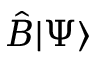<formula> <loc_0><loc_0><loc_500><loc_500>{ \hat { B } } | \Psi \rangle</formula> 